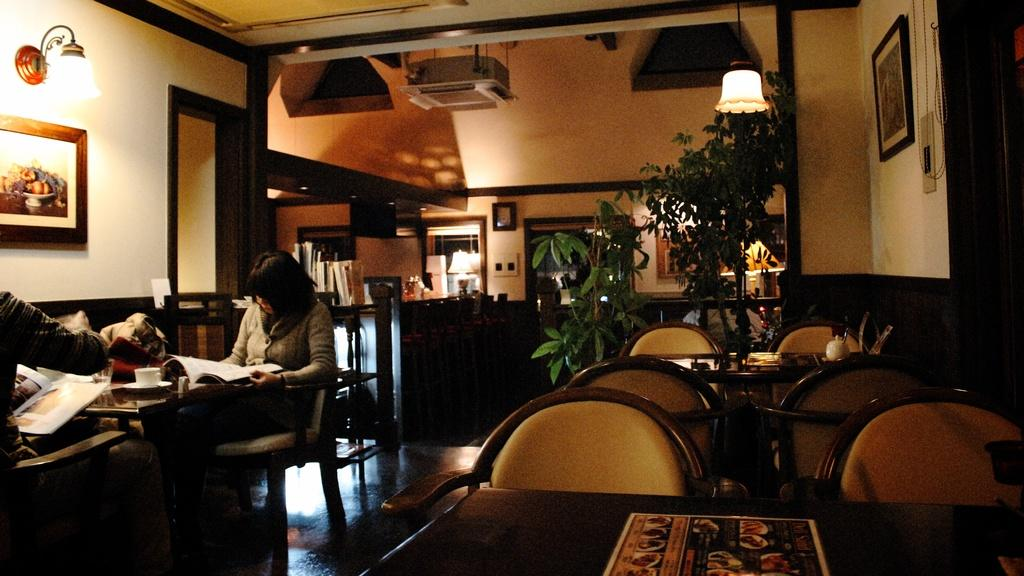What is the woman in the image doing? The woman is sitting in a room and reading a book. What furniture is present in the room? There are tables and a chair in the room. What can be seen on the wall in the image? There are photo frames on the wall. What type of decorative elements are present in the room? There are plants in the room. What type of attraction is the woman visiting in the image? There is no indication of an attraction in the image; it shows a woman sitting in a room reading a book. Are there any police officers present in the image? No, there are no police officers present in the image. 